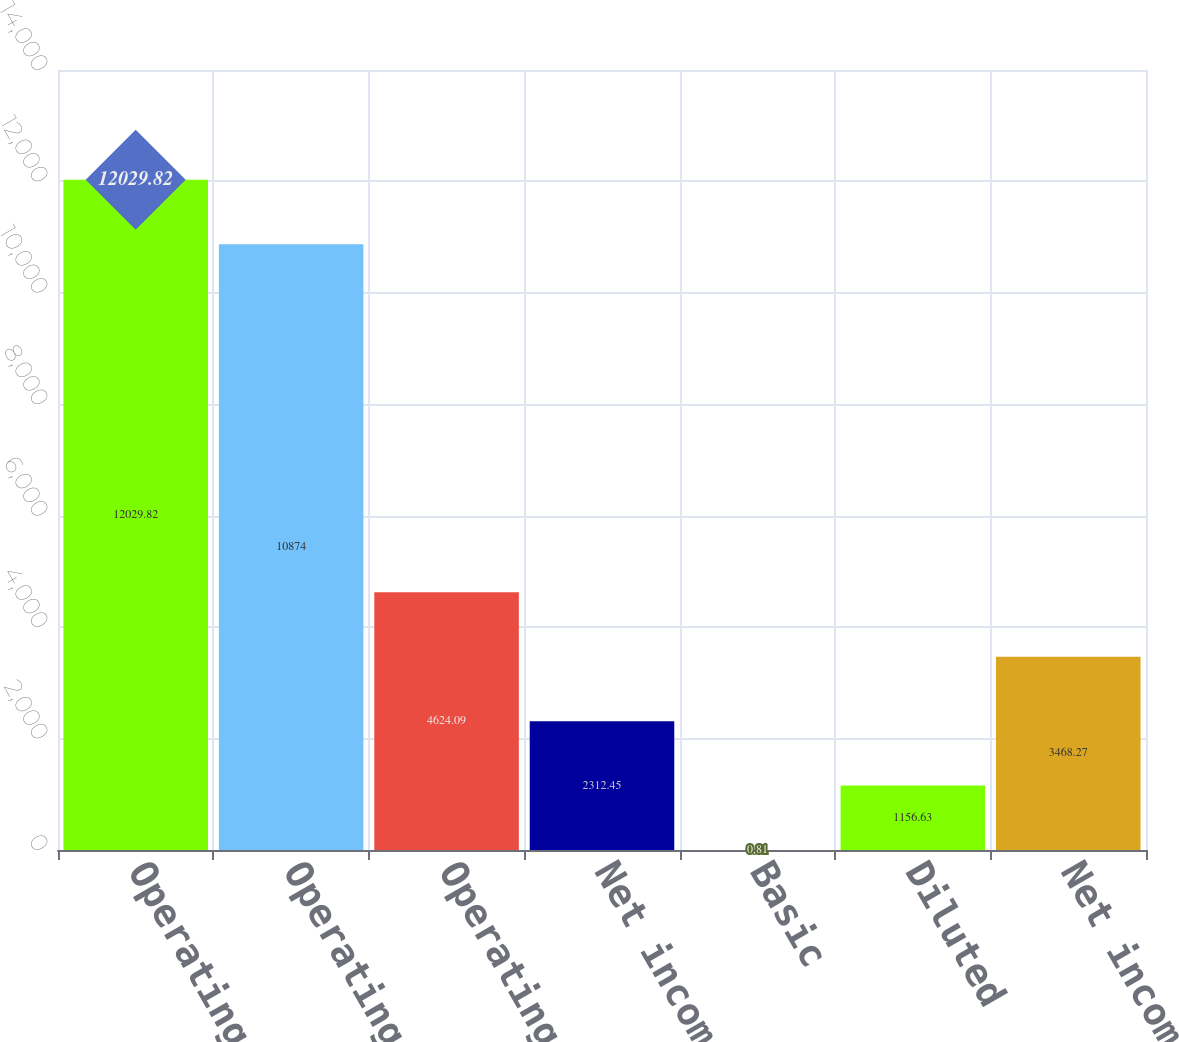Convert chart to OTSL. <chart><loc_0><loc_0><loc_500><loc_500><bar_chart><fcel>Operating revenues<fcel>Operating expenses<fcel>Operating income<fcel>Net income<fcel>Basic<fcel>Diluted<fcel>Net income (loss)<nl><fcel>12029.8<fcel>10874<fcel>4624.09<fcel>2312.45<fcel>0.81<fcel>1156.63<fcel>3468.27<nl></chart> 